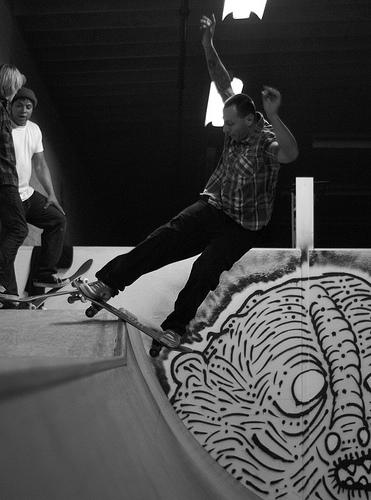What type of print is the man raising his hands wearing on his shirt? Please explain your reasoning. plaid. He is wearing a plaid shirt. 